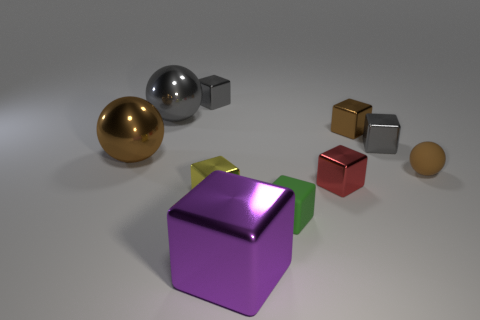What size is the purple thing that is the same material as the big brown sphere?
Offer a terse response. Large. How many gray objects have the same shape as the small brown shiny thing?
Provide a succinct answer. 2. Does the tiny metal object in front of the red metallic cube have the same color as the small matte sphere?
Your answer should be very brief. No. What number of small green matte things are to the right of the big gray metal sphere that is to the left of the gray metal cube to the left of the large purple metallic thing?
Give a very brief answer. 1. How many tiny matte objects are to the left of the small red block and behind the tiny green rubber object?
Your response must be concise. 0. There is a large object that is the same color as the matte sphere; what is its shape?
Keep it short and to the point. Sphere. Do the small green thing and the small red block have the same material?
Offer a terse response. No. The brown shiny object to the left of the gray cube on the left side of the rubber thing that is in front of the yellow metal block is what shape?
Give a very brief answer. Sphere. Are there fewer red metallic blocks in front of the big block than small green rubber objects to the right of the small brown block?
Your answer should be compact. No. What shape is the brown thing that is on the left side of the big object that is in front of the small ball?
Give a very brief answer. Sphere. 